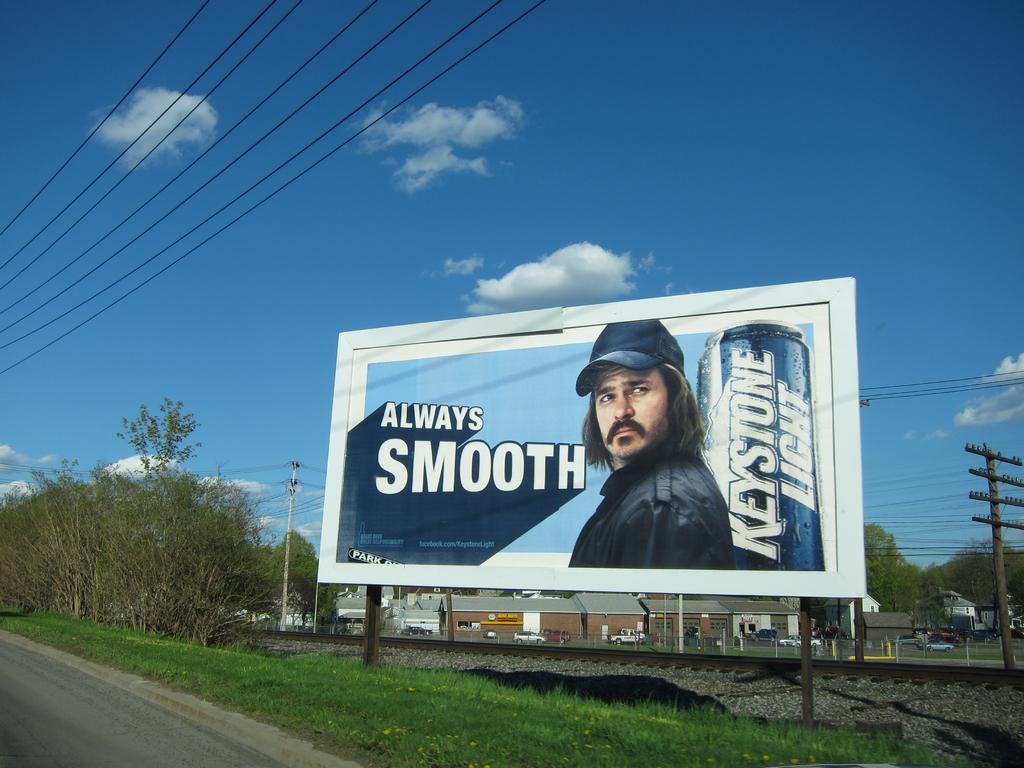Provide a one-sentence caption for the provided image. A billboard ad with "always smooth", advertising beer. 